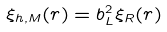Convert formula to latex. <formula><loc_0><loc_0><loc_500><loc_500>\xi _ { h , M } ( r ) = b _ { L } ^ { 2 } \xi _ { R } ( r )</formula> 